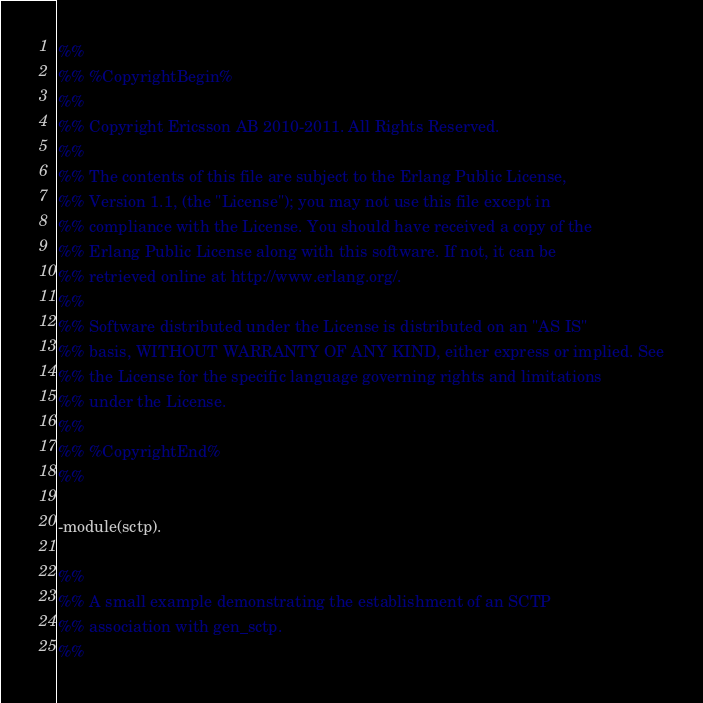Convert code to text. <code><loc_0><loc_0><loc_500><loc_500><_Erlang_>%%
%% %CopyrightBegin%
%%
%% Copyright Ericsson AB 2010-2011. All Rights Reserved.
%%
%% The contents of this file are subject to the Erlang Public License,
%% Version 1.1, (the "License"); you may not use this file except in
%% compliance with the License. You should have received a copy of the
%% Erlang Public License along with this software. If not, it can be
%% retrieved online at http://www.erlang.org/.
%%
%% Software distributed under the License is distributed on an "AS IS"
%% basis, WITHOUT WARRANTY OF ANY KIND, either express or implied. See
%% the License for the specific language governing rights and limitations
%% under the License.
%%
%% %CopyrightEnd%
%%

-module(sctp).

%%
%% A small example demonstrating the establishment of an SCTP
%% association with gen_sctp.
%%
</code> 